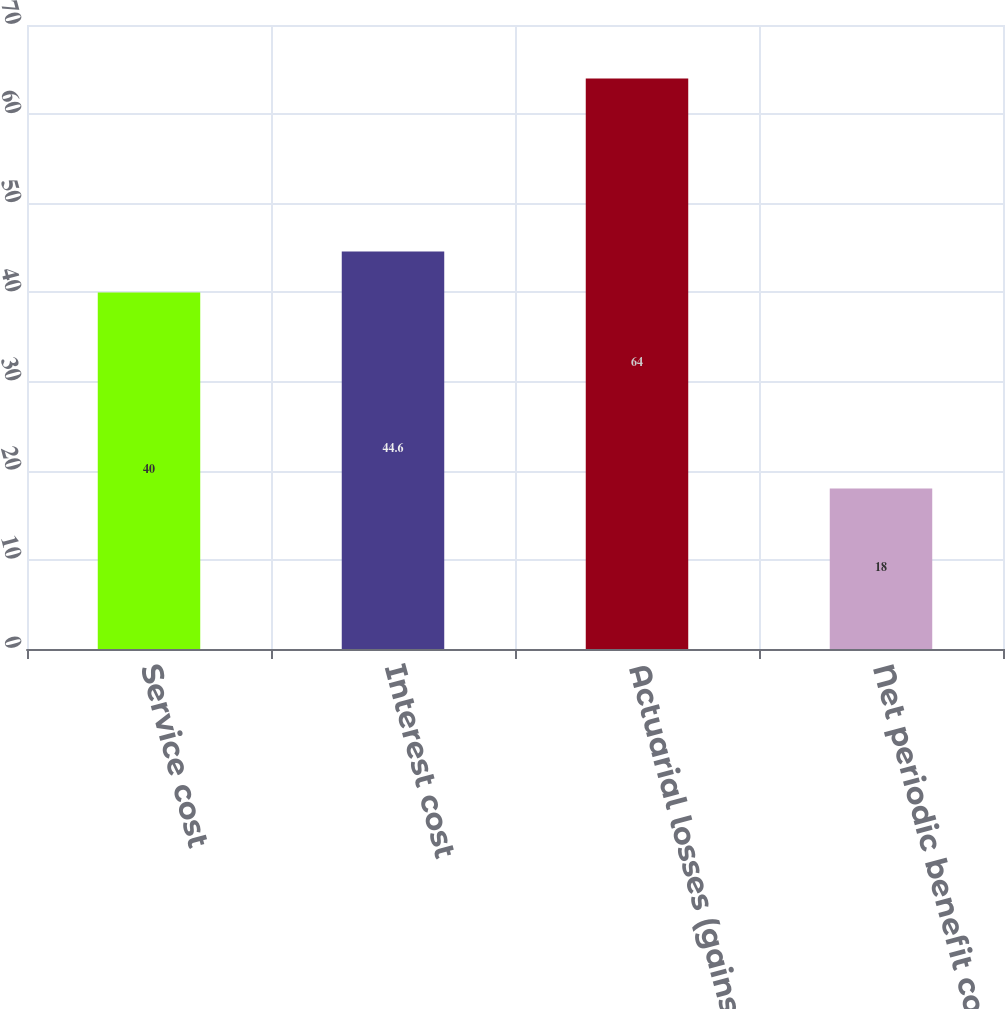<chart> <loc_0><loc_0><loc_500><loc_500><bar_chart><fcel>Service cost<fcel>Interest cost<fcel>Actuarial losses (gains) and<fcel>Net periodic benefit cost<nl><fcel>40<fcel>44.6<fcel>64<fcel>18<nl></chart> 